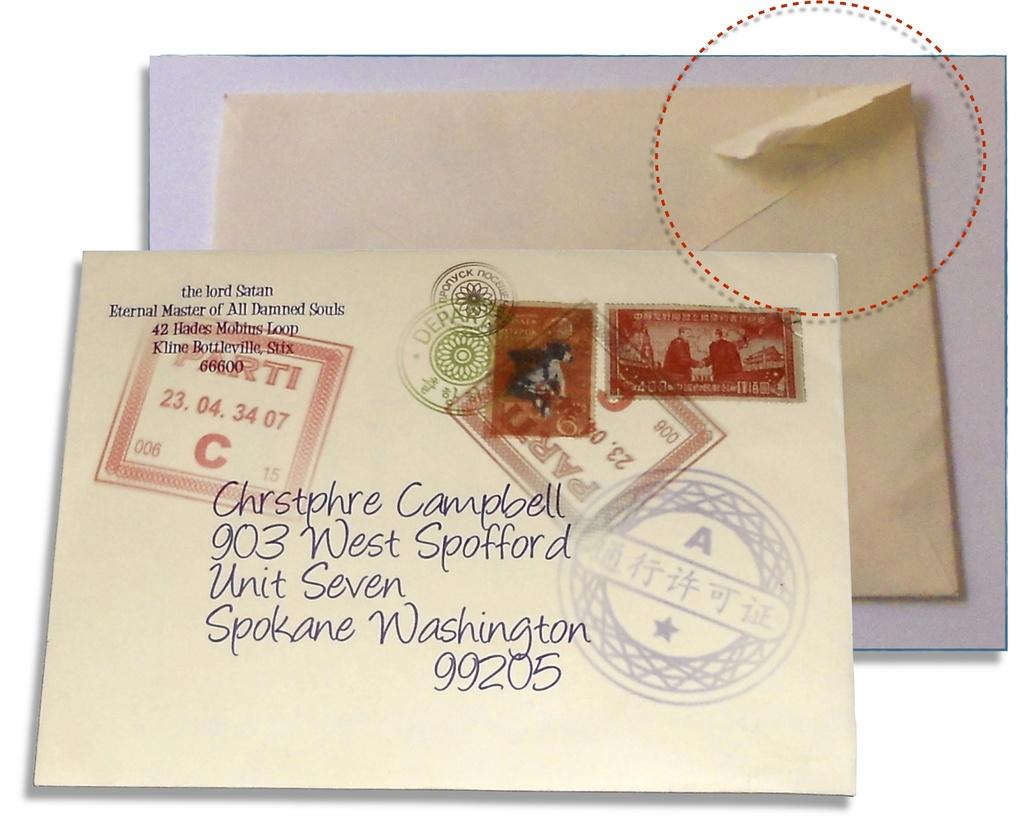<image>
Offer a succinct explanation of the picture presented. A letter is addressed to someone in Spokane, Washington. 